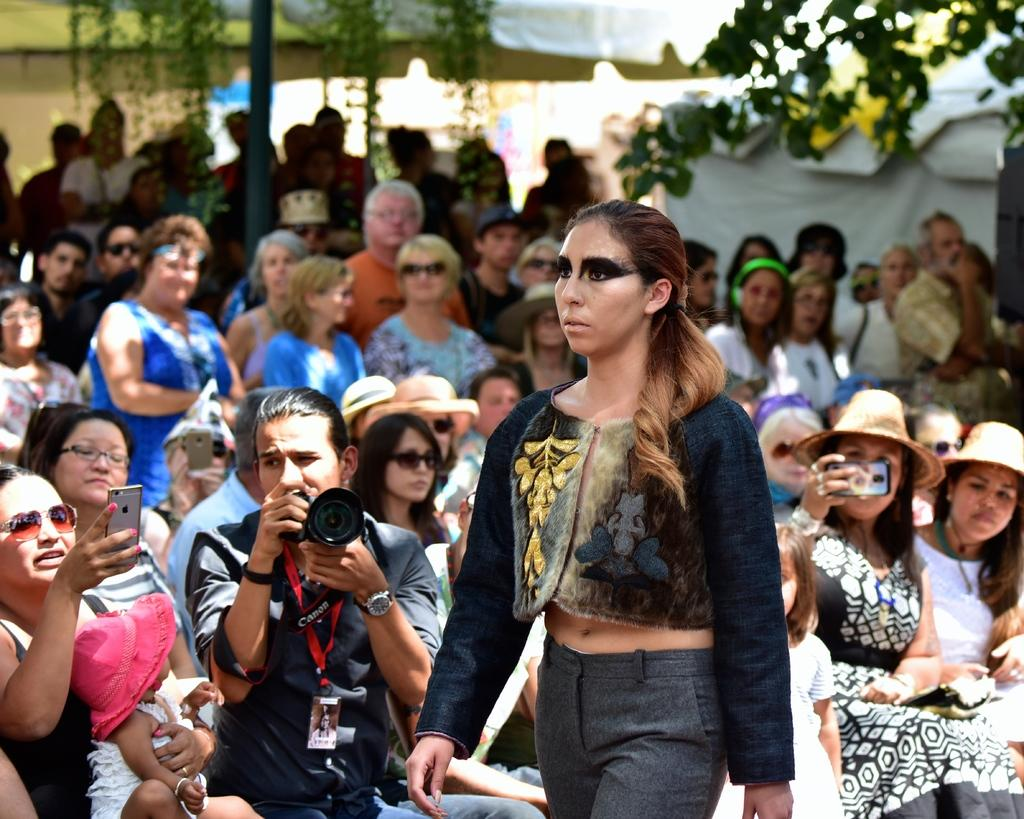Who or what can be seen in the image? There are people in the image. What are some of the people doing in the image? Some of the people are holding phones, while others are holding a camera. Can you describe the attire of the people in the image? Most of the people are wearing hats. What can be seen in the background of the image? There is a tree visible in the background of the image. What type of celery is being used to take a picture in the image? There is no celery present in the image, and it is not being used to take a picture. 